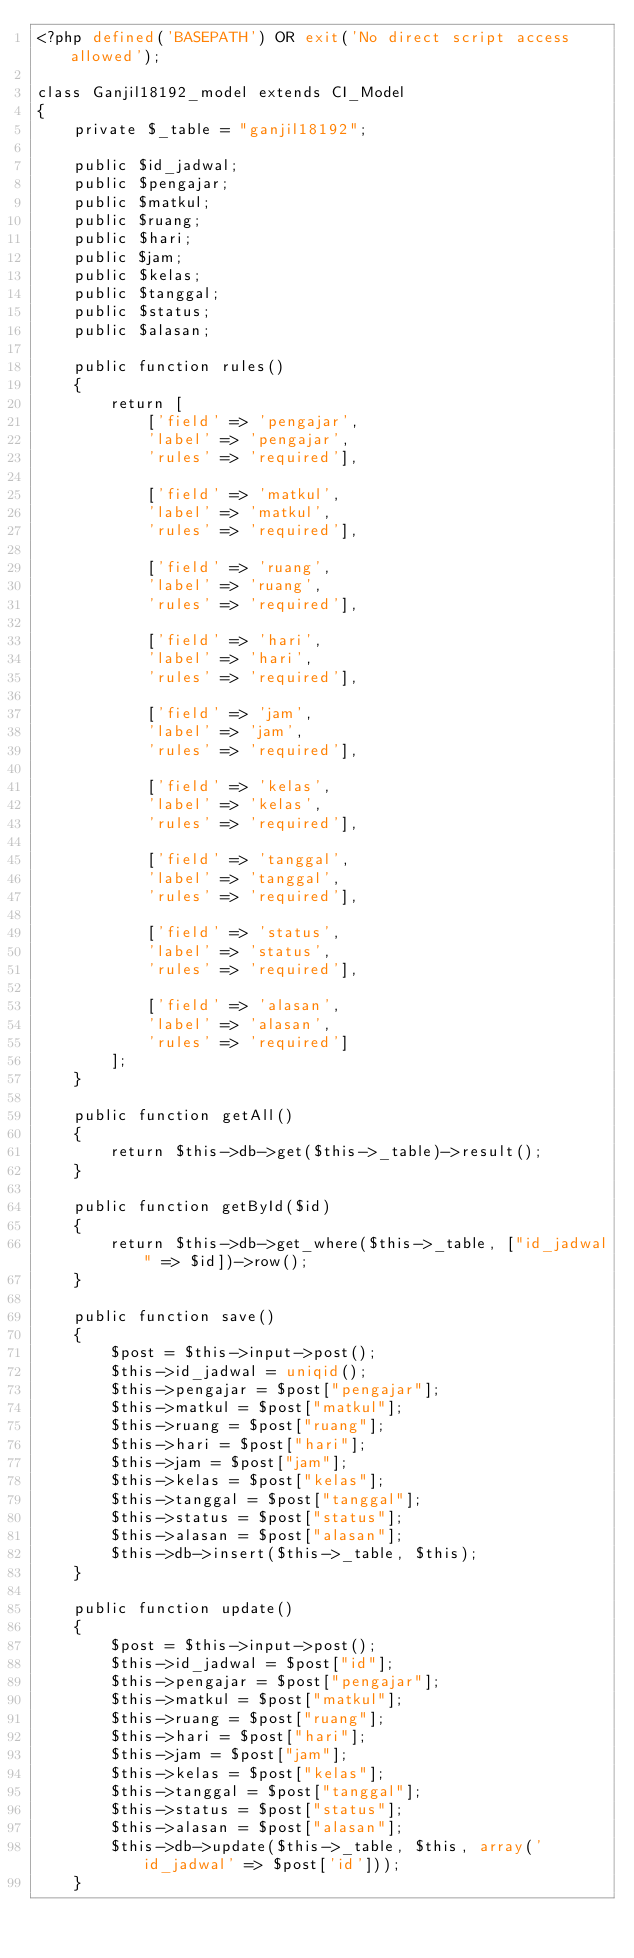<code> <loc_0><loc_0><loc_500><loc_500><_PHP_><?php defined('BASEPATH') OR exit('No direct script access allowed');

class Ganjil18192_model extends CI_Model
{
    private $_table = "ganjil18192";

    public $id_jadwal;
    public $pengajar;
    public $matkul;
    public $ruang;
    public $hari;
    public $jam;
    public $kelas;
    public $tanggal;
    public $status;
    public $alasan;

    public function rules()
    {
        return [
            ['field' => 'pengajar',
            'label' => 'pengajar',
            'rules' => 'required'],

            ['field' => 'matkul',
            'label' => 'matkul',
            'rules' => 'required'],

            ['field' => 'ruang',
            'label' => 'ruang',
            'rules' => 'required'],

            ['field' => 'hari',
            'label' => 'hari',
            'rules' => 'required'],

            ['field' => 'jam',
            'label' => 'jam',
            'rules' => 'required'],

            ['field' => 'kelas',
            'label' => 'kelas',
            'rules' => 'required'],

            ['field' => 'tanggal',
            'label' => 'tanggal',
            'rules' => 'required'],

            ['field' => 'status',
            'label' => 'status',
            'rules' => 'required'],

            ['field' => 'alasan',
            'label' => 'alasan',
            'rules' => 'required']
        ];
    }

    public function getAll()
    {
        return $this->db->get($this->_table)->result();
    }
    
    public function getById($id)
    {
        return $this->db->get_where($this->_table, ["id_jadwal" => $id])->row();
    }

    public function save()
    {
        $post = $this->input->post();
        $this->id_jadwal = uniqid();
        $this->pengajar = $post["pengajar"];
        $this->matkul = $post["matkul"];
        $this->ruang = $post["ruang"];
        $this->hari = $post["hari"];
        $this->jam = $post["jam"];
        $this->kelas = $post["kelas"];
        $this->tanggal = $post["tanggal"];
        $this->status = $post["status"];
        $this->alasan = $post["alasan"];
        $this->db->insert($this->_table, $this);
    }

    public function update()
    {
        $post = $this->input->post();
        $this->id_jadwal = $post["id"];
        $this->pengajar = $post["pengajar"];
        $this->matkul = $post["matkul"];
        $this->ruang = $post["ruang"];
        $this->hari = $post["hari"];
        $this->jam = $post["jam"];
        $this->kelas = $post["kelas"];
        $this->tanggal = $post["tanggal"];
        $this->status = $post["status"];
        $this->alasan = $post["alasan"];
        $this->db->update($this->_table, $this, array('id_jadwal' => $post['id']));
    }
</code> 